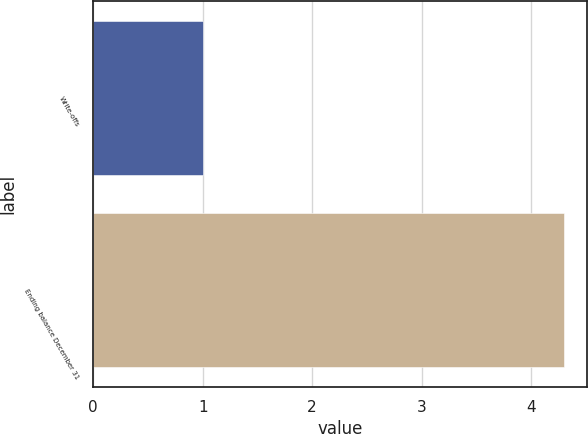Convert chart. <chart><loc_0><loc_0><loc_500><loc_500><bar_chart><fcel>Write-offs<fcel>Ending balance December 31<nl><fcel>1<fcel>4.3<nl></chart> 